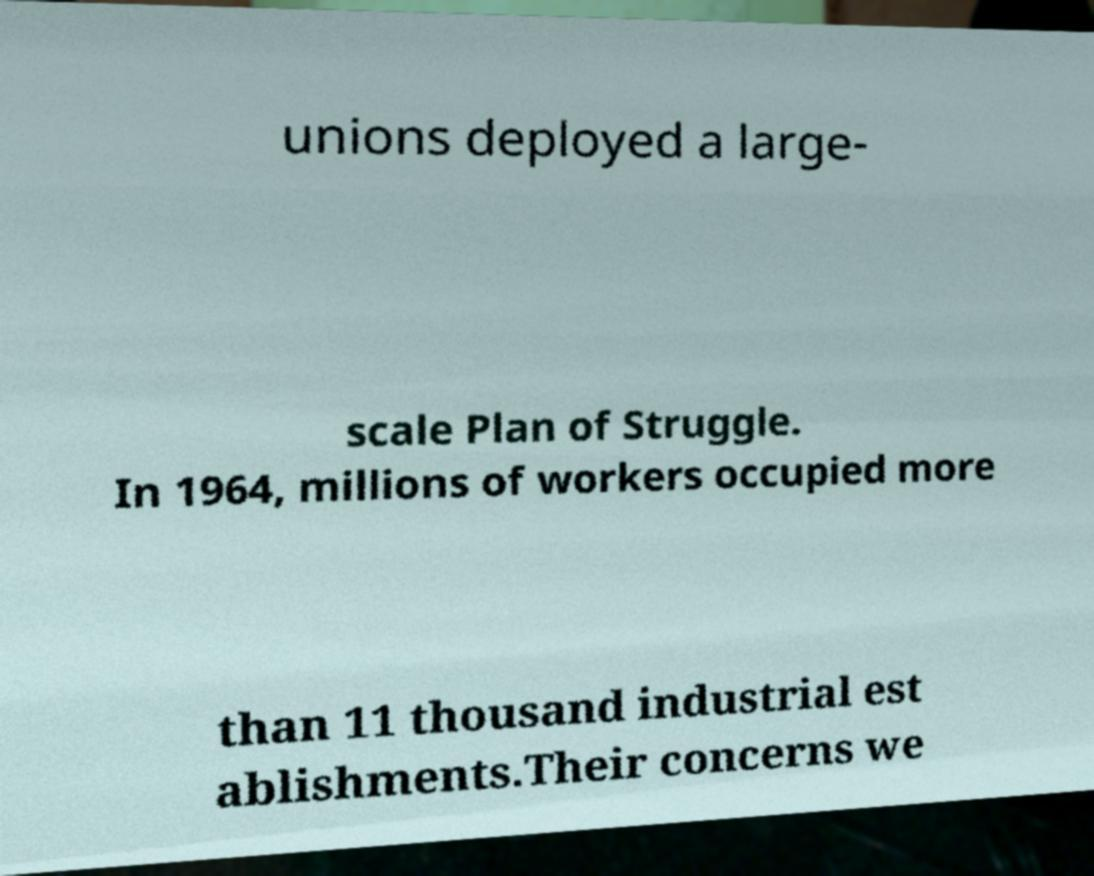Could you extract and type out the text from this image? unions deployed a large- scale Plan of Struggle. In 1964, millions of workers occupied more than 11 thousand industrial est ablishments.Their concerns we 